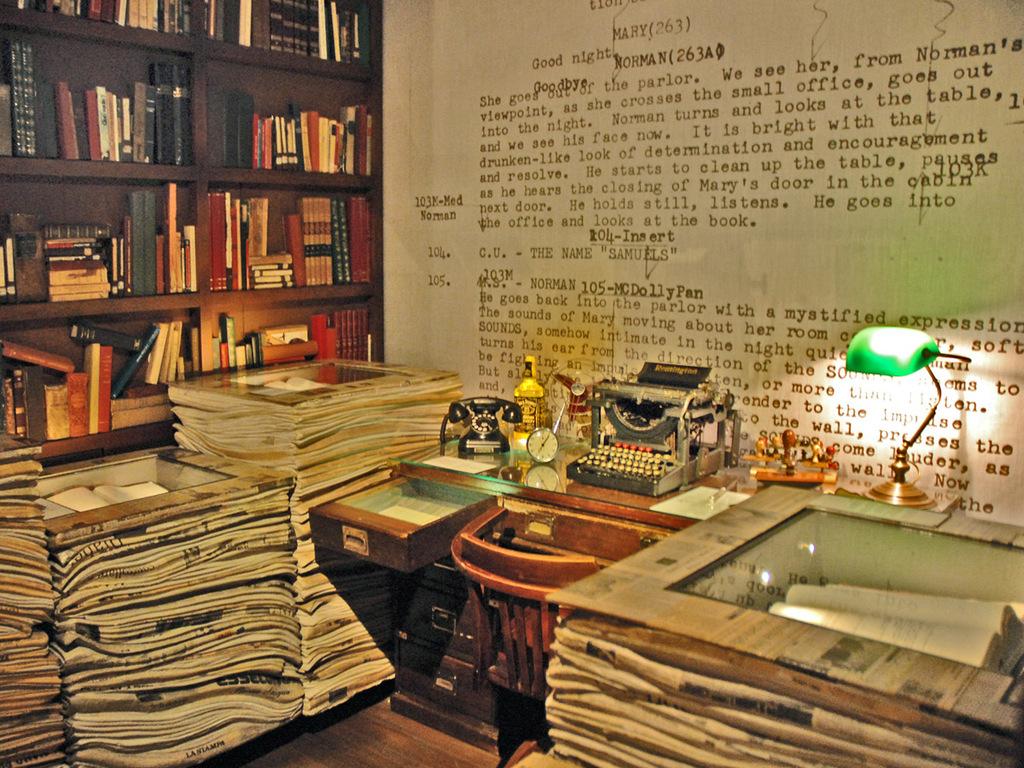What number is next to mary's name at the top?
Give a very brief answer. 263. 